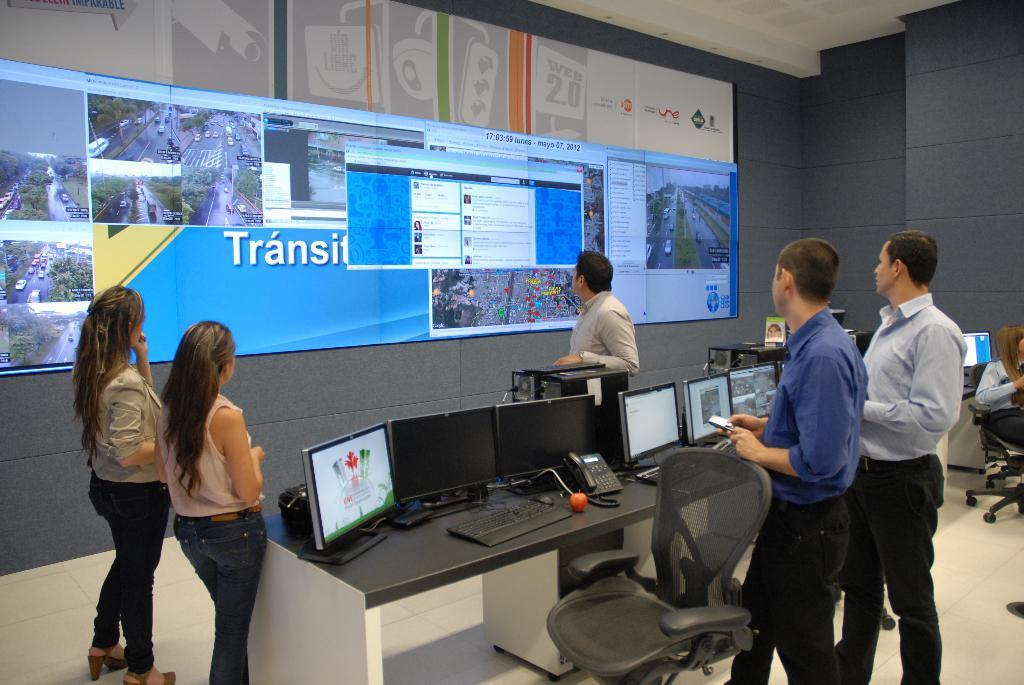In one or two sentences, can you explain what this image depicts? A screen is on wall. This persons are standing. In-front of this person there is a table, on a table there is a telephone, keyboard, mouse and monitors. This is chair. This woman is sitting on a chair. 